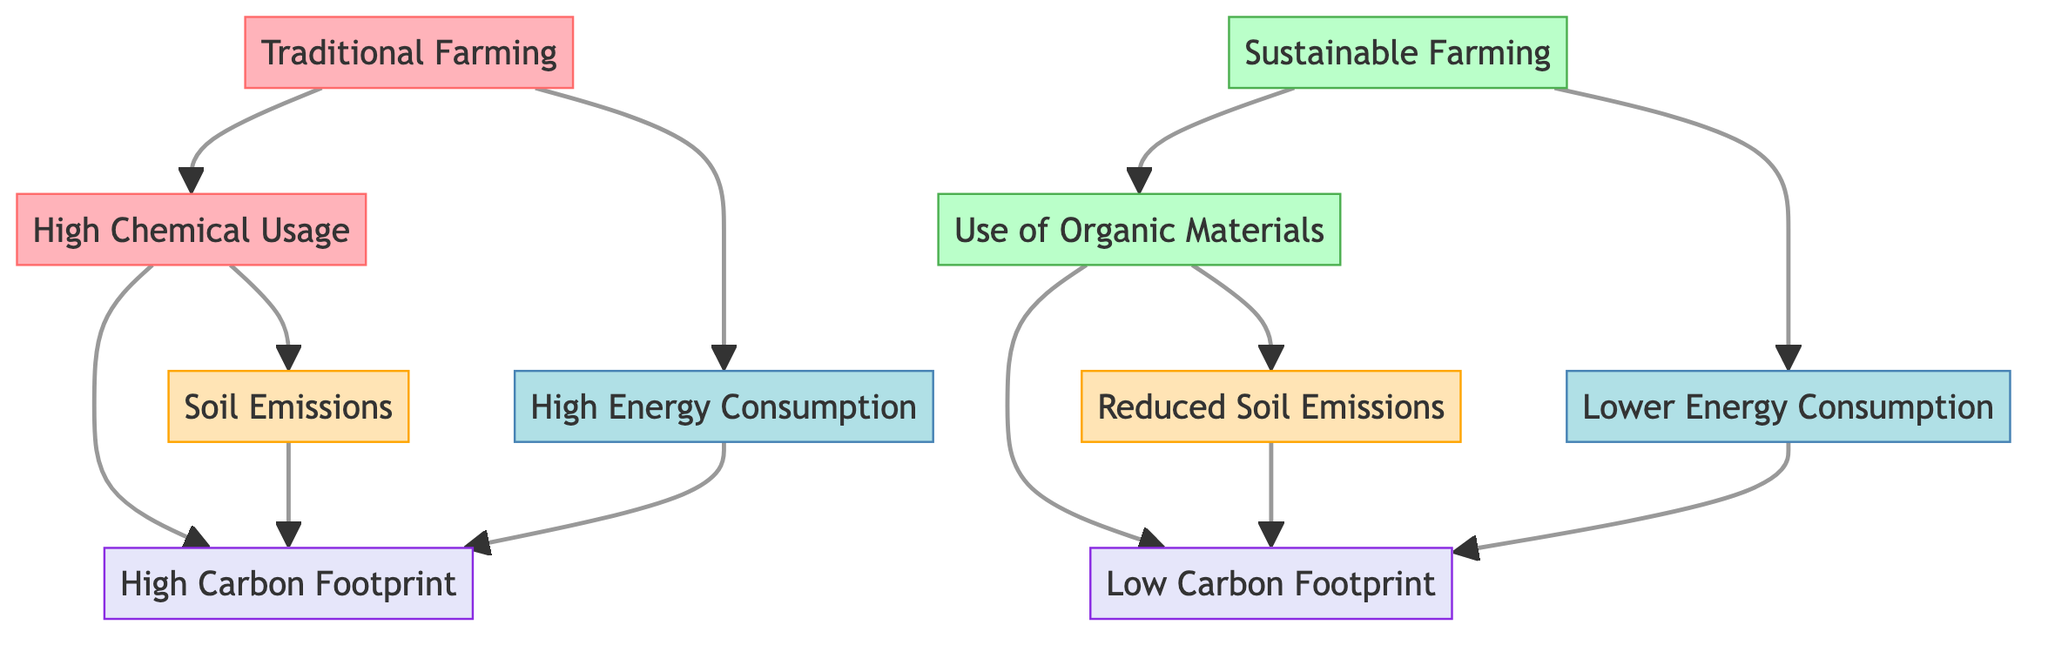What are the two types of farming shown in the diagram? The diagram presents two main types of farming: Traditional Farming and Sustainable Farming. These titles are clearly labeled at the top of each respective section of the flowchart.
Answer: Traditional Farming and Sustainable Farming What is the main source of high carbon footprint in traditional farming? In the traditional farming section, it is shown that high chemical usage directly contributes to the carbon footprint. The flowchart illustrates this by connecting high chemical usage to soil emissions and directly to the carbon footprint.
Answer: High chemical usage What aspect contributes to lower carbon footprint in sustainable farming? The flowchart indicates that the use of organic materials in sustainable farming leads to reduced soil emissions, which then contribute to a lower carbon footprint. This shows a direct connection from organic materials to the carbon footprint.
Answer: Use of organic materials How many nodes are there related to energy consumption in the diagram? There are two nodes related to energy consumption: one for traditional farming and one for sustainable farming. Each type of farming shows its respective energy consumption characteristics, resulting in a total of two nodes.
Answer: 2 Which type of farming has a lower carbon footprint? The flowchart clearly indicates that sustainable farming results in a low carbon footprint, while traditional farming has a high carbon footprint. The nodes are labeled with descriptions reflecting their carbon footprint levels.
Answer: Sustainable farming How does high energy consumption relate to the carbon footprint in traditional farming? The flowchart represents that high energy consumption is one of the contributing factors leading to a high carbon footprint in traditional farming. This connection is made explicit as the flow leads from energy consumption to carbon footprint.
Answer: It leads to high carbon footprint What is the color scheme used to differentiate between traditional and sustainable farming? Traditional farming is represented with shades of red (fill color: light pink and stroke: red), while sustainable farming is shown using shades of green (fill color: light green and stroke: green). This color coding visually distinguishes the two types of farming in the diagram.
Answer: Red and green What is the direct result of using organic materials in sustainable farming? The diagram shows that using organic materials in sustainable farming leads to reduced soil emissions. This connection is clearly illustrated by the arrow pointing from the use of organic materials to reduced soil emissions.
Answer: Reduced soil emissions 